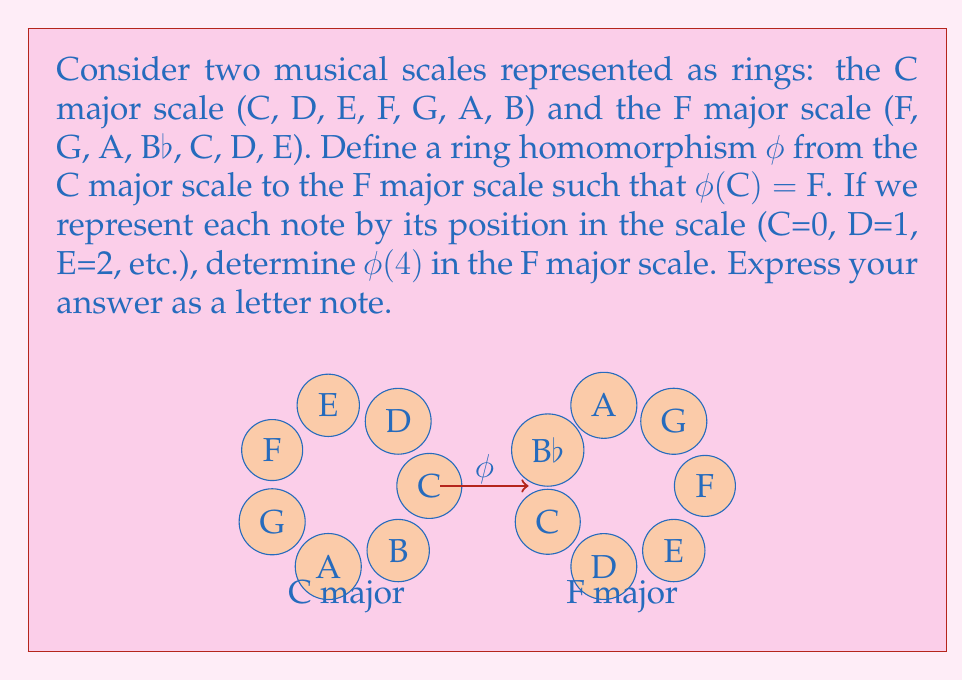Help me with this question. Let's approach this step-by-step:

1) In ring theory, a homomorphism $\phi$ between two rings must preserve both addition and multiplication operations.

2) In musical scales, we can define addition as moving up the scale and multiplication as interval preservation.

3) Given $\phi(C) = F$, we know that the homomorphism shifts the scale by 4 semitones (as F is the 4th note in the C major scale).

4) In the C major scale, the note at position 4 is G.

5) To find $\phi(4)$, we need to shift G by 4 semitones in the F major scale.

6) In the F major scale:
   F (0) → G (1) → A (2) → Bb (3) → C (4)

7) Therefore, $\phi(4)$ corresponds to C in the F major scale.

8) We can verify this mathematically:
   $\phi(4) = \phi(0 + 4) = \phi(0) + \phi(4) = F + 4 = C$ in the F major scale

This preserves the ring structure as required by the homomorphism.
Answer: C 